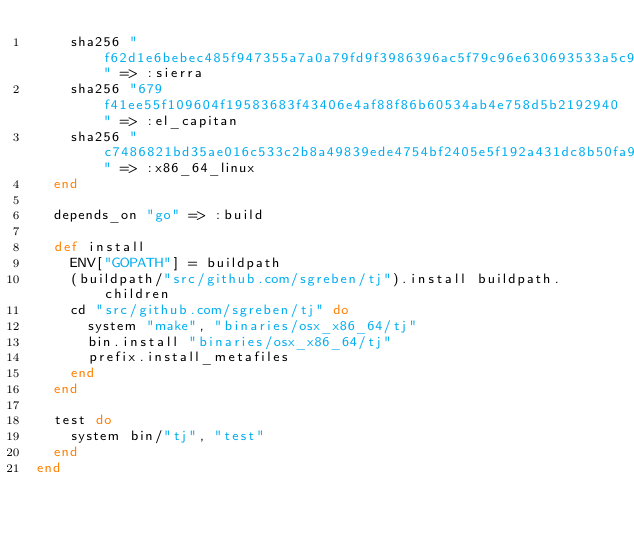<code> <loc_0><loc_0><loc_500><loc_500><_Ruby_>    sha256 "f62d1e6bebec485f947355a7a0a79fd9f3986396ac5f79c96e630693533a5c9d" => :sierra
    sha256 "679f41ee55f109604f19583683f43406e4af88f86b60534ab4e758d5b2192940" => :el_capitan
    sha256 "c7486821bd35ae016c533c2b8a49839ede4754bf2405e5f192a431dc8b50fa99" => :x86_64_linux
  end

  depends_on "go" => :build

  def install
    ENV["GOPATH"] = buildpath
    (buildpath/"src/github.com/sgreben/tj").install buildpath.children
    cd "src/github.com/sgreben/tj" do
      system "make", "binaries/osx_x86_64/tj"
      bin.install "binaries/osx_x86_64/tj"
      prefix.install_metafiles
    end
  end

  test do
    system bin/"tj", "test"
  end
end
</code> 